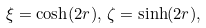<formula> <loc_0><loc_0><loc_500><loc_500>\xi = \cosh ( 2 r ) , \, \zeta = \sinh ( 2 r ) ,</formula> 